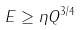<formula> <loc_0><loc_0><loc_500><loc_500>E \geq \eta Q ^ { 3 / 4 }</formula> 